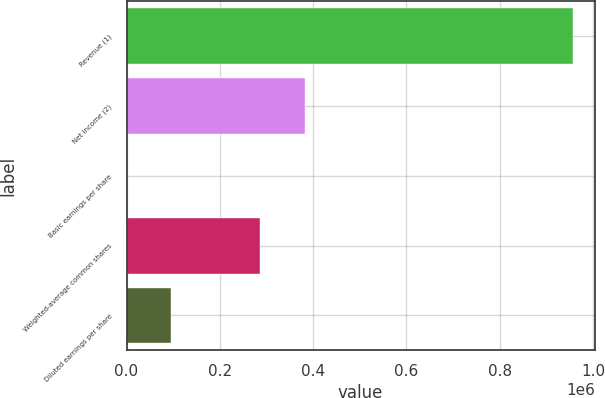Convert chart to OTSL. <chart><loc_0><loc_0><loc_500><loc_500><bar_chart><fcel>Revenue (1)<fcel>Net income (2)<fcel>Basic earnings per share<fcel>Weighted-average common shares<fcel>Diluted earnings per share<nl><fcel>956280<fcel>382513<fcel>1.99<fcel>286885<fcel>95629.8<nl></chart> 